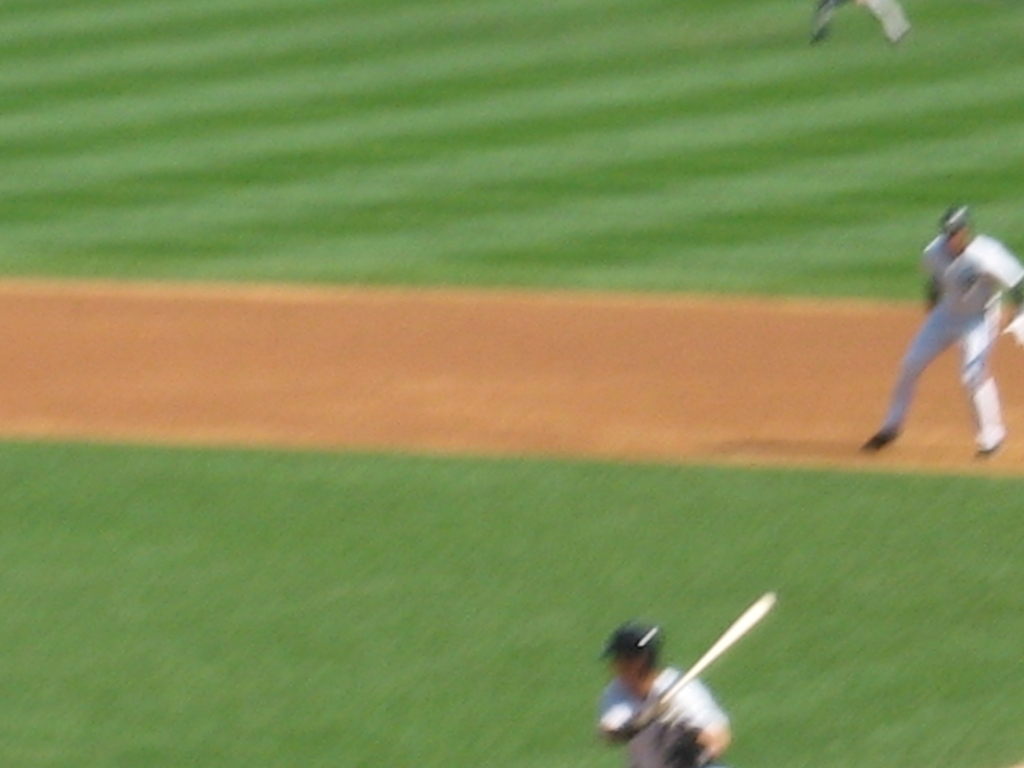What activity is being captured in this image? The image is capturing a moment in a baseball game, with a batter at the plate ready to swing and a pitcher in the middle of a pitch. Can you tell which team is at bat based on their uniforms? Unfortunately, due to the image's blur, discerning the team based on uniforms isn't possible. The uniforms lack distinct markings or logos that could be used for identification. 